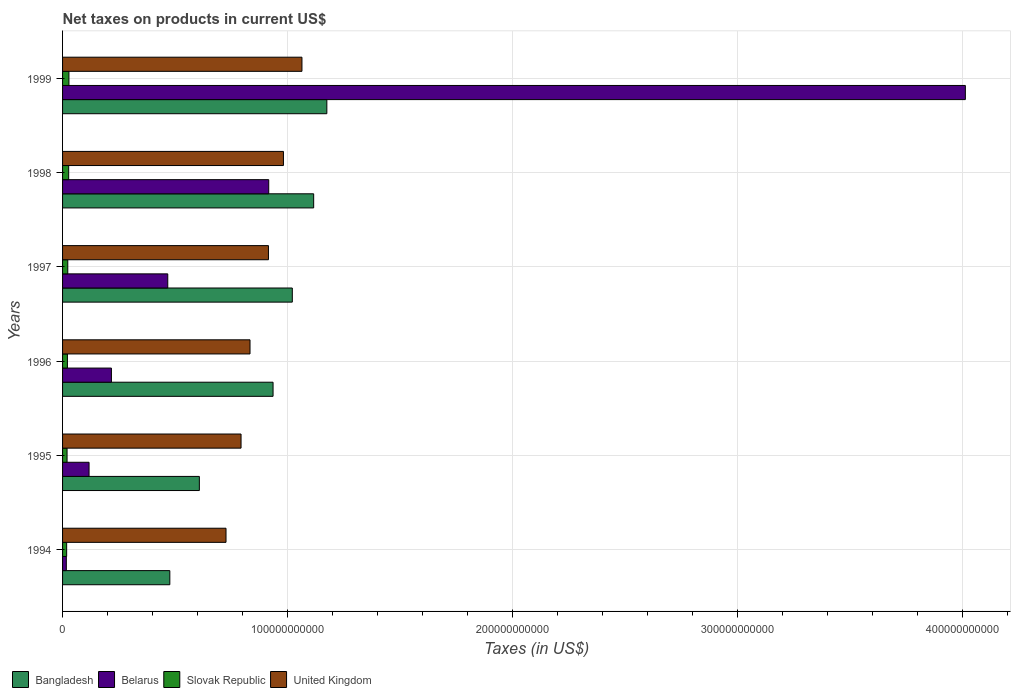How many different coloured bars are there?
Your response must be concise. 4. Are the number of bars per tick equal to the number of legend labels?
Your response must be concise. Yes. How many bars are there on the 4th tick from the top?
Give a very brief answer. 4. How many bars are there on the 5th tick from the bottom?
Your response must be concise. 4. In how many cases, is the number of bars for a given year not equal to the number of legend labels?
Make the answer very short. 0. What is the net taxes on products in Bangladesh in 1997?
Provide a succinct answer. 1.02e+11. Across all years, what is the maximum net taxes on products in United Kingdom?
Keep it short and to the point. 1.06e+11. Across all years, what is the minimum net taxes on products in Bangladesh?
Offer a very short reply. 4.77e+1. What is the total net taxes on products in United Kingdom in the graph?
Ensure brevity in your answer.  5.31e+11. What is the difference between the net taxes on products in United Kingdom in 1997 and that in 1999?
Give a very brief answer. -1.49e+1. What is the difference between the net taxes on products in Bangladesh in 1996 and the net taxes on products in United Kingdom in 1998?
Your answer should be very brief. -4.62e+09. What is the average net taxes on products in Bangladesh per year?
Keep it short and to the point. 8.89e+1. In the year 1994, what is the difference between the net taxes on products in United Kingdom and net taxes on products in Belarus?
Offer a terse response. 7.10e+1. In how many years, is the net taxes on products in United Kingdom greater than 280000000000 US$?
Your answer should be compact. 0. What is the ratio of the net taxes on products in Slovak Republic in 1995 to that in 1999?
Your answer should be very brief. 0.71. Is the difference between the net taxes on products in United Kingdom in 1994 and 1996 greater than the difference between the net taxes on products in Belarus in 1994 and 1996?
Give a very brief answer. Yes. What is the difference between the highest and the second highest net taxes on products in Slovak Republic?
Provide a short and direct response. 1.12e+08. What is the difference between the highest and the lowest net taxes on products in Belarus?
Your response must be concise. 4.00e+11. In how many years, is the net taxes on products in Slovak Republic greater than the average net taxes on products in Slovak Republic taken over all years?
Your answer should be very brief. 3. Is the sum of the net taxes on products in Slovak Republic in 1994 and 1998 greater than the maximum net taxes on products in Bangladesh across all years?
Offer a very short reply. No. Is it the case that in every year, the sum of the net taxes on products in Slovak Republic and net taxes on products in Belarus is greater than the sum of net taxes on products in United Kingdom and net taxes on products in Bangladesh?
Provide a short and direct response. No. What does the 2nd bar from the bottom in 1999 represents?
Your answer should be compact. Belarus. Is it the case that in every year, the sum of the net taxes on products in United Kingdom and net taxes on products in Belarus is greater than the net taxes on products in Bangladesh?
Provide a succinct answer. Yes. How many bars are there?
Ensure brevity in your answer.  24. What is the difference between two consecutive major ticks on the X-axis?
Your answer should be compact. 1.00e+11. Does the graph contain any zero values?
Keep it short and to the point. No. Does the graph contain grids?
Keep it short and to the point. Yes. How are the legend labels stacked?
Your answer should be very brief. Horizontal. What is the title of the graph?
Your answer should be compact. Net taxes on products in current US$. Does "Congo (Democratic)" appear as one of the legend labels in the graph?
Your response must be concise. No. What is the label or title of the X-axis?
Your response must be concise. Taxes (in US$). What is the Taxes (in US$) in Bangladesh in 1994?
Provide a succinct answer. 4.77e+1. What is the Taxes (in US$) of Belarus in 1994?
Offer a terse response. 1.67e+09. What is the Taxes (in US$) in Slovak Republic in 1994?
Offer a terse response. 1.82e+09. What is the Taxes (in US$) in United Kingdom in 1994?
Offer a terse response. 7.26e+1. What is the Taxes (in US$) in Bangladesh in 1995?
Your response must be concise. 6.08e+1. What is the Taxes (in US$) of Belarus in 1995?
Provide a short and direct response. 1.18e+1. What is the Taxes (in US$) of Slovak Republic in 1995?
Provide a succinct answer. 2.00e+09. What is the Taxes (in US$) in United Kingdom in 1995?
Make the answer very short. 7.93e+1. What is the Taxes (in US$) of Bangladesh in 1996?
Make the answer very short. 9.36e+1. What is the Taxes (in US$) in Belarus in 1996?
Offer a terse response. 2.17e+1. What is the Taxes (in US$) of Slovak Republic in 1996?
Your response must be concise. 2.15e+09. What is the Taxes (in US$) in United Kingdom in 1996?
Offer a very short reply. 8.33e+1. What is the Taxes (in US$) of Bangladesh in 1997?
Your response must be concise. 1.02e+11. What is the Taxes (in US$) in Belarus in 1997?
Offer a terse response. 4.68e+1. What is the Taxes (in US$) in Slovak Republic in 1997?
Your answer should be very brief. 2.31e+09. What is the Taxes (in US$) of United Kingdom in 1997?
Offer a terse response. 9.15e+1. What is the Taxes (in US$) of Bangladesh in 1998?
Ensure brevity in your answer.  1.12e+11. What is the Taxes (in US$) of Belarus in 1998?
Your response must be concise. 9.16e+1. What is the Taxes (in US$) of Slovak Republic in 1998?
Provide a succinct answer. 2.72e+09. What is the Taxes (in US$) in United Kingdom in 1998?
Offer a very short reply. 9.82e+1. What is the Taxes (in US$) of Bangladesh in 1999?
Give a very brief answer. 1.17e+11. What is the Taxes (in US$) of Belarus in 1999?
Ensure brevity in your answer.  4.01e+11. What is the Taxes (in US$) of Slovak Republic in 1999?
Your response must be concise. 2.83e+09. What is the Taxes (in US$) in United Kingdom in 1999?
Provide a succinct answer. 1.06e+11. Across all years, what is the maximum Taxes (in US$) of Bangladesh?
Offer a terse response. 1.17e+11. Across all years, what is the maximum Taxes (in US$) in Belarus?
Make the answer very short. 4.01e+11. Across all years, what is the maximum Taxes (in US$) of Slovak Republic?
Ensure brevity in your answer.  2.83e+09. Across all years, what is the maximum Taxes (in US$) in United Kingdom?
Give a very brief answer. 1.06e+11. Across all years, what is the minimum Taxes (in US$) in Bangladesh?
Offer a very short reply. 4.77e+1. Across all years, what is the minimum Taxes (in US$) of Belarus?
Make the answer very short. 1.67e+09. Across all years, what is the minimum Taxes (in US$) of Slovak Republic?
Ensure brevity in your answer.  1.82e+09. Across all years, what is the minimum Taxes (in US$) in United Kingdom?
Offer a terse response. 7.26e+1. What is the total Taxes (in US$) in Bangladesh in the graph?
Give a very brief answer. 5.33e+11. What is the total Taxes (in US$) in Belarus in the graph?
Ensure brevity in your answer.  5.75e+11. What is the total Taxes (in US$) of Slovak Republic in the graph?
Your answer should be very brief. 1.38e+1. What is the total Taxes (in US$) of United Kingdom in the graph?
Make the answer very short. 5.31e+11. What is the difference between the Taxes (in US$) in Bangladesh in 1994 and that in 1995?
Provide a short and direct response. -1.31e+1. What is the difference between the Taxes (in US$) of Belarus in 1994 and that in 1995?
Offer a very short reply. -1.01e+1. What is the difference between the Taxes (in US$) in Slovak Republic in 1994 and that in 1995?
Ensure brevity in your answer.  -1.81e+08. What is the difference between the Taxes (in US$) of United Kingdom in 1994 and that in 1995?
Provide a short and direct response. -6.69e+09. What is the difference between the Taxes (in US$) in Bangladesh in 1994 and that in 1996?
Provide a succinct answer. -4.59e+1. What is the difference between the Taxes (in US$) in Belarus in 1994 and that in 1996?
Your response must be concise. -2.00e+1. What is the difference between the Taxes (in US$) of Slovak Republic in 1994 and that in 1996?
Make the answer very short. -3.37e+08. What is the difference between the Taxes (in US$) in United Kingdom in 1994 and that in 1996?
Offer a very short reply. -1.07e+1. What is the difference between the Taxes (in US$) of Bangladesh in 1994 and that in 1997?
Provide a succinct answer. -5.44e+1. What is the difference between the Taxes (in US$) of Belarus in 1994 and that in 1997?
Provide a succinct answer. -4.51e+1. What is the difference between the Taxes (in US$) of Slovak Republic in 1994 and that in 1997?
Give a very brief answer. -4.97e+08. What is the difference between the Taxes (in US$) in United Kingdom in 1994 and that in 1997?
Make the answer very short. -1.89e+1. What is the difference between the Taxes (in US$) in Bangladesh in 1994 and that in 1998?
Make the answer very short. -6.39e+1. What is the difference between the Taxes (in US$) of Belarus in 1994 and that in 1998?
Make the answer very short. -9.00e+1. What is the difference between the Taxes (in US$) in Slovak Republic in 1994 and that in 1998?
Your response must be concise. -9.05e+08. What is the difference between the Taxes (in US$) in United Kingdom in 1994 and that in 1998?
Provide a succinct answer. -2.55e+1. What is the difference between the Taxes (in US$) in Bangladesh in 1994 and that in 1999?
Give a very brief answer. -6.98e+1. What is the difference between the Taxes (in US$) in Belarus in 1994 and that in 1999?
Provide a succinct answer. -4.00e+11. What is the difference between the Taxes (in US$) of Slovak Republic in 1994 and that in 1999?
Offer a very short reply. -1.02e+09. What is the difference between the Taxes (in US$) in United Kingdom in 1994 and that in 1999?
Keep it short and to the point. -3.38e+1. What is the difference between the Taxes (in US$) of Bangladesh in 1995 and that in 1996?
Make the answer very short. -3.28e+1. What is the difference between the Taxes (in US$) of Belarus in 1995 and that in 1996?
Your answer should be compact. -9.93e+09. What is the difference between the Taxes (in US$) in Slovak Republic in 1995 and that in 1996?
Your response must be concise. -1.56e+08. What is the difference between the Taxes (in US$) of United Kingdom in 1995 and that in 1996?
Your answer should be compact. -3.98e+09. What is the difference between the Taxes (in US$) of Bangladesh in 1995 and that in 1997?
Your response must be concise. -4.13e+1. What is the difference between the Taxes (in US$) of Belarus in 1995 and that in 1997?
Ensure brevity in your answer.  -3.50e+1. What is the difference between the Taxes (in US$) in Slovak Republic in 1995 and that in 1997?
Offer a terse response. -3.16e+08. What is the difference between the Taxes (in US$) in United Kingdom in 1995 and that in 1997?
Provide a succinct answer. -1.22e+1. What is the difference between the Taxes (in US$) in Bangladesh in 1995 and that in 1998?
Your answer should be compact. -5.08e+1. What is the difference between the Taxes (in US$) in Belarus in 1995 and that in 1998?
Offer a terse response. -7.99e+1. What is the difference between the Taxes (in US$) in Slovak Republic in 1995 and that in 1998?
Keep it short and to the point. -7.24e+08. What is the difference between the Taxes (in US$) of United Kingdom in 1995 and that in 1998?
Keep it short and to the point. -1.88e+1. What is the difference between the Taxes (in US$) in Bangladesh in 1995 and that in 1999?
Your answer should be very brief. -5.67e+1. What is the difference between the Taxes (in US$) of Belarus in 1995 and that in 1999?
Make the answer very short. -3.89e+11. What is the difference between the Taxes (in US$) of Slovak Republic in 1995 and that in 1999?
Provide a short and direct response. -8.36e+08. What is the difference between the Taxes (in US$) of United Kingdom in 1995 and that in 1999?
Your answer should be very brief. -2.71e+1. What is the difference between the Taxes (in US$) in Bangladesh in 1996 and that in 1997?
Your answer should be very brief. -8.56e+09. What is the difference between the Taxes (in US$) in Belarus in 1996 and that in 1997?
Provide a succinct answer. -2.50e+1. What is the difference between the Taxes (in US$) in Slovak Republic in 1996 and that in 1997?
Ensure brevity in your answer.  -1.60e+08. What is the difference between the Taxes (in US$) in United Kingdom in 1996 and that in 1997?
Provide a short and direct response. -8.19e+09. What is the difference between the Taxes (in US$) in Bangladesh in 1996 and that in 1998?
Keep it short and to the point. -1.81e+1. What is the difference between the Taxes (in US$) of Belarus in 1996 and that in 1998?
Offer a terse response. -6.99e+1. What is the difference between the Taxes (in US$) of Slovak Republic in 1996 and that in 1998?
Give a very brief answer. -5.68e+08. What is the difference between the Taxes (in US$) in United Kingdom in 1996 and that in 1998?
Keep it short and to the point. -1.49e+1. What is the difference between the Taxes (in US$) of Bangladesh in 1996 and that in 1999?
Provide a short and direct response. -2.39e+1. What is the difference between the Taxes (in US$) in Belarus in 1996 and that in 1999?
Your answer should be compact. -3.80e+11. What is the difference between the Taxes (in US$) in Slovak Republic in 1996 and that in 1999?
Your response must be concise. -6.80e+08. What is the difference between the Taxes (in US$) of United Kingdom in 1996 and that in 1999?
Ensure brevity in your answer.  -2.31e+1. What is the difference between the Taxes (in US$) of Bangladesh in 1997 and that in 1998?
Provide a succinct answer. -9.50e+09. What is the difference between the Taxes (in US$) of Belarus in 1997 and that in 1998?
Provide a short and direct response. -4.49e+1. What is the difference between the Taxes (in US$) in Slovak Republic in 1997 and that in 1998?
Offer a terse response. -4.08e+08. What is the difference between the Taxes (in US$) in United Kingdom in 1997 and that in 1998?
Your response must be concise. -6.66e+09. What is the difference between the Taxes (in US$) of Bangladesh in 1997 and that in 1999?
Offer a terse response. -1.53e+1. What is the difference between the Taxes (in US$) in Belarus in 1997 and that in 1999?
Provide a short and direct response. -3.55e+11. What is the difference between the Taxes (in US$) of Slovak Republic in 1997 and that in 1999?
Provide a succinct answer. -5.20e+08. What is the difference between the Taxes (in US$) in United Kingdom in 1997 and that in 1999?
Make the answer very short. -1.49e+1. What is the difference between the Taxes (in US$) of Bangladesh in 1998 and that in 1999?
Offer a terse response. -5.85e+09. What is the difference between the Taxes (in US$) of Belarus in 1998 and that in 1999?
Provide a succinct answer. -3.10e+11. What is the difference between the Taxes (in US$) of Slovak Republic in 1998 and that in 1999?
Make the answer very short. -1.12e+08. What is the difference between the Taxes (in US$) of United Kingdom in 1998 and that in 1999?
Your answer should be very brief. -8.23e+09. What is the difference between the Taxes (in US$) in Bangladesh in 1994 and the Taxes (in US$) in Belarus in 1995?
Give a very brief answer. 3.59e+1. What is the difference between the Taxes (in US$) of Bangladesh in 1994 and the Taxes (in US$) of Slovak Republic in 1995?
Offer a terse response. 4.57e+1. What is the difference between the Taxes (in US$) of Bangladesh in 1994 and the Taxes (in US$) of United Kingdom in 1995?
Make the answer very short. -3.17e+1. What is the difference between the Taxes (in US$) of Belarus in 1994 and the Taxes (in US$) of Slovak Republic in 1995?
Your response must be concise. -3.25e+08. What is the difference between the Taxes (in US$) in Belarus in 1994 and the Taxes (in US$) in United Kingdom in 1995?
Keep it short and to the point. -7.77e+1. What is the difference between the Taxes (in US$) in Slovak Republic in 1994 and the Taxes (in US$) in United Kingdom in 1995?
Your answer should be compact. -7.75e+1. What is the difference between the Taxes (in US$) in Bangladesh in 1994 and the Taxes (in US$) in Belarus in 1996?
Offer a very short reply. 2.60e+1. What is the difference between the Taxes (in US$) in Bangladesh in 1994 and the Taxes (in US$) in Slovak Republic in 1996?
Give a very brief answer. 4.55e+1. What is the difference between the Taxes (in US$) of Bangladesh in 1994 and the Taxes (in US$) of United Kingdom in 1996?
Your answer should be compact. -3.56e+1. What is the difference between the Taxes (in US$) of Belarus in 1994 and the Taxes (in US$) of Slovak Republic in 1996?
Give a very brief answer. -4.81e+08. What is the difference between the Taxes (in US$) of Belarus in 1994 and the Taxes (in US$) of United Kingdom in 1996?
Offer a very short reply. -8.16e+1. What is the difference between the Taxes (in US$) of Slovak Republic in 1994 and the Taxes (in US$) of United Kingdom in 1996?
Your response must be concise. -8.15e+1. What is the difference between the Taxes (in US$) of Bangladesh in 1994 and the Taxes (in US$) of Belarus in 1997?
Provide a succinct answer. 9.21e+08. What is the difference between the Taxes (in US$) of Bangladesh in 1994 and the Taxes (in US$) of Slovak Republic in 1997?
Ensure brevity in your answer.  4.54e+1. What is the difference between the Taxes (in US$) in Bangladesh in 1994 and the Taxes (in US$) in United Kingdom in 1997?
Your response must be concise. -4.38e+1. What is the difference between the Taxes (in US$) of Belarus in 1994 and the Taxes (in US$) of Slovak Republic in 1997?
Give a very brief answer. -6.41e+08. What is the difference between the Taxes (in US$) of Belarus in 1994 and the Taxes (in US$) of United Kingdom in 1997?
Provide a succinct answer. -8.98e+1. What is the difference between the Taxes (in US$) of Slovak Republic in 1994 and the Taxes (in US$) of United Kingdom in 1997?
Keep it short and to the point. -8.97e+1. What is the difference between the Taxes (in US$) of Bangladesh in 1994 and the Taxes (in US$) of Belarus in 1998?
Offer a terse response. -4.40e+1. What is the difference between the Taxes (in US$) in Bangladesh in 1994 and the Taxes (in US$) in Slovak Republic in 1998?
Your answer should be compact. 4.50e+1. What is the difference between the Taxes (in US$) in Bangladesh in 1994 and the Taxes (in US$) in United Kingdom in 1998?
Your answer should be compact. -5.05e+1. What is the difference between the Taxes (in US$) in Belarus in 1994 and the Taxes (in US$) in Slovak Republic in 1998?
Make the answer very short. -1.05e+09. What is the difference between the Taxes (in US$) of Belarus in 1994 and the Taxes (in US$) of United Kingdom in 1998?
Ensure brevity in your answer.  -9.65e+1. What is the difference between the Taxes (in US$) in Slovak Republic in 1994 and the Taxes (in US$) in United Kingdom in 1998?
Make the answer very short. -9.64e+1. What is the difference between the Taxes (in US$) of Bangladesh in 1994 and the Taxes (in US$) of Belarus in 1999?
Your answer should be compact. -3.54e+11. What is the difference between the Taxes (in US$) of Bangladesh in 1994 and the Taxes (in US$) of Slovak Republic in 1999?
Offer a very short reply. 4.48e+1. What is the difference between the Taxes (in US$) of Bangladesh in 1994 and the Taxes (in US$) of United Kingdom in 1999?
Your response must be concise. -5.87e+1. What is the difference between the Taxes (in US$) in Belarus in 1994 and the Taxes (in US$) in Slovak Republic in 1999?
Your answer should be compact. -1.16e+09. What is the difference between the Taxes (in US$) of Belarus in 1994 and the Taxes (in US$) of United Kingdom in 1999?
Provide a short and direct response. -1.05e+11. What is the difference between the Taxes (in US$) in Slovak Republic in 1994 and the Taxes (in US$) in United Kingdom in 1999?
Provide a short and direct response. -1.05e+11. What is the difference between the Taxes (in US$) of Bangladesh in 1995 and the Taxes (in US$) of Belarus in 1996?
Give a very brief answer. 3.91e+1. What is the difference between the Taxes (in US$) in Bangladesh in 1995 and the Taxes (in US$) in Slovak Republic in 1996?
Provide a short and direct response. 5.86e+1. What is the difference between the Taxes (in US$) in Bangladesh in 1995 and the Taxes (in US$) in United Kingdom in 1996?
Make the answer very short. -2.25e+1. What is the difference between the Taxes (in US$) in Belarus in 1995 and the Taxes (in US$) in Slovak Republic in 1996?
Provide a short and direct response. 9.62e+09. What is the difference between the Taxes (in US$) of Belarus in 1995 and the Taxes (in US$) of United Kingdom in 1996?
Make the answer very short. -7.15e+1. What is the difference between the Taxes (in US$) in Slovak Republic in 1995 and the Taxes (in US$) in United Kingdom in 1996?
Offer a terse response. -8.13e+1. What is the difference between the Taxes (in US$) in Bangladesh in 1995 and the Taxes (in US$) in Belarus in 1997?
Keep it short and to the point. 1.40e+1. What is the difference between the Taxes (in US$) of Bangladesh in 1995 and the Taxes (in US$) of Slovak Republic in 1997?
Ensure brevity in your answer.  5.85e+1. What is the difference between the Taxes (in US$) in Bangladesh in 1995 and the Taxes (in US$) in United Kingdom in 1997?
Keep it short and to the point. -3.07e+1. What is the difference between the Taxes (in US$) in Belarus in 1995 and the Taxes (in US$) in Slovak Republic in 1997?
Your answer should be compact. 9.46e+09. What is the difference between the Taxes (in US$) in Belarus in 1995 and the Taxes (in US$) in United Kingdom in 1997?
Your answer should be very brief. -7.97e+1. What is the difference between the Taxes (in US$) of Slovak Republic in 1995 and the Taxes (in US$) of United Kingdom in 1997?
Your answer should be very brief. -8.95e+1. What is the difference between the Taxes (in US$) of Bangladesh in 1995 and the Taxes (in US$) of Belarus in 1998?
Offer a very short reply. -3.08e+1. What is the difference between the Taxes (in US$) in Bangladesh in 1995 and the Taxes (in US$) in Slovak Republic in 1998?
Keep it short and to the point. 5.81e+1. What is the difference between the Taxes (in US$) of Bangladesh in 1995 and the Taxes (in US$) of United Kingdom in 1998?
Your response must be concise. -3.74e+1. What is the difference between the Taxes (in US$) of Belarus in 1995 and the Taxes (in US$) of Slovak Republic in 1998?
Give a very brief answer. 9.05e+09. What is the difference between the Taxes (in US$) of Belarus in 1995 and the Taxes (in US$) of United Kingdom in 1998?
Offer a terse response. -8.64e+1. What is the difference between the Taxes (in US$) in Slovak Republic in 1995 and the Taxes (in US$) in United Kingdom in 1998?
Offer a very short reply. -9.62e+1. What is the difference between the Taxes (in US$) of Bangladesh in 1995 and the Taxes (in US$) of Belarus in 1999?
Provide a short and direct response. -3.40e+11. What is the difference between the Taxes (in US$) in Bangladesh in 1995 and the Taxes (in US$) in Slovak Republic in 1999?
Offer a terse response. 5.80e+1. What is the difference between the Taxes (in US$) of Bangladesh in 1995 and the Taxes (in US$) of United Kingdom in 1999?
Provide a short and direct response. -4.56e+1. What is the difference between the Taxes (in US$) of Belarus in 1995 and the Taxes (in US$) of Slovak Republic in 1999?
Offer a very short reply. 8.94e+09. What is the difference between the Taxes (in US$) of Belarus in 1995 and the Taxes (in US$) of United Kingdom in 1999?
Ensure brevity in your answer.  -9.46e+1. What is the difference between the Taxes (in US$) in Slovak Republic in 1995 and the Taxes (in US$) in United Kingdom in 1999?
Give a very brief answer. -1.04e+11. What is the difference between the Taxes (in US$) of Bangladesh in 1996 and the Taxes (in US$) of Belarus in 1997?
Provide a succinct answer. 4.68e+1. What is the difference between the Taxes (in US$) of Bangladesh in 1996 and the Taxes (in US$) of Slovak Republic in 1997?
Give a very brief answer. 9.12e+1. What is the difference between the Taxes (in US$) in Bangladesh in 1996 and the Taxes (in US$) in United Kingdom in 1997?
Keep it short and to the point. 2.05e+09. What is the difference between the Taxes (in US$) of Belarus in 1996 and the Taxes (in US$) of Slovak Republic in 1997?
Your answer should be very brief. 1.94e+1. What is the difference between the Taxes (in US$) in Belarus in 1996 and the Taxes (in US$) in United Kingdom in 1997?
Offer a very short reply. -6.98e+1. What is the difference between the Taxes (in US$) of Slovak Republic in 1996 and the Taxes (in US$) of United Kingdom in 1997?
Give a very brief answer. -8.94e+1. What is the difference between the Taxes (in US$) in Bangladesh in 1996 and the Taxes (in US$) in Belarus in 1998?
Keep it short and to the point. 1.92e+09. What is the difference between the Taxes (in US$) of Bangladesh in 1996 and the Taxes (in US$) of Slovak Republic in 1998?
Offer a very short reply. 9.08e+1. What is the difference between the Taxes (in US$) of Bangladesh in 1996 and the Taxes (in US$) of United Kingdom in 1998?
Your response must be concise. -4.62e+09. What is the difference between the Taxes (in US$) in Belarus in 1996 and the Taxes (in US$) in Slovak Republic in 1998?
Keep it short and to the point. 1.90e+1. What is the difference between the Taxes (in US$) in Belarus in 1996 and the Taxes (in US$) in United Kingdom in 1998?
Offer a terse response. -7.65e+1. What is the difference between the Taxes (in US$) of Slovak Republic in 1996 and the Taxes (in US$) of United Kingdom in 1998?
Provide a short and direct response. -9.60e+1. What is the difference between the Taxes (in US$) of Bangladesh in 1996 and the Taxes (in US$) of Belarus in 1999?
Make the answer very short. -3.08e+11. What is the difference between the Taxes (in US$) of Bangladesh in 1996 and the Taxes (in US$) of Slovak Republic in 1999?
Your answer should be very brief. 9.07e+1. What is the difference between the Taxes (in US$) of Bangladesh in 1996 and the Taxes (in US$) of United Kingdom in 1999?
Offer a terse response. -1.28e+1. What is the difference between the Taxes (in US$) of Belarus in 1996 and the Taxes (in US$) of Slovak Republic in 1999?
Provide a succinct answer. 1.89e+1. What is the difference between the Taxes (in US$) in Belarus in 1996 and the Taxes (in US$) in United Kingdom in 1999?
Provide a short and direct response. -8.47e+1. What is the difference between the Taxes (in US$) in Slovak Republic in 1996 and the Taxes (in US$) in United Kingdom in 1999?
Make the answer very short. -1.04e+11. What is the difference between the Taxes (in US$) in Bangladesh in 1997 and the Taxes (in US$) in Belarus in 1998?
Give a very brief answer. 1.05e+1. What is the difference between the Taxes (in US$) in Bangladesh in 1997 and the Taxes (in US$) in Slovak Republic in 1998?
Keep it short and to the point. 9.94e+1. What is the difference between the Taxes (in US$) of Bangladesh in 1997 and the Taxes (in US$) of United Kingdom in 1998?
Make the answer very short. 3.94e+09. What is the difference between the Taxes (in US$) in Belarus in 1997 and the Taxes (in US$) in Slovak Republic in 1998?
Give a very brief answer. 4.40e+1. What is the difference between the Taxes (in US$) of Belarus in 1997 and the Taxes (in US$) of United Kingdom in 1998?
Make the answer very short. -5.14e+1. What is the difference between the Taxes (in US$) of Slovak Republic in 1997 and the Taxes (in US$) of United Kingdom in 1998?
Keep it short and to the point. -9.59e+1. What is the difference between the Taxes (in US$) of Bangladesh in 1997 and the Taxes (in US$) of Belarus in 1999?
Give a very brief answer. -2.99e+11. What is the difference between the Taxes (in US$) of Bangladesh in 1997 and the Taxes (in US$) of Slovak Republic in 1999?
Offer a very short reply. 9.93e+1. What is the difference between the Taxes (in US$) of Bangladesh in 1997 and the Taxes (in US$) of United Kingdom in 1999?
Make the answer very short. -4.29e+09. What is the difference between the Taxes (in US$) of Belarus in 1997 and the Taxes (in US$) of Slovak Republic in 1999?
Offer a terse response. 4.39e+1. What is the difference between the Taxes (in US$) of Belarus in 1997 and the Taxes (in US$) of United Kingdom in 1999?
Keep it short and to the point. -5.96e+1. What is the difference between the Taxes (in US$) in Slovak Republic in 1997 and the Taxes (in US$) in United Kingdom in 1999?
Provide a succinct answer. -1.04e+11. What is the difference between the Taxes (in US$) in Bangladesh in 1998 and the Taxes (in US$) in Belarus in 1999?
Your answer should be compact. -2.90e+11. What is the difference between the Taxes (in US$) in Bangladesh in 1998 and the Taxes (in US$) in Slovak Republic in 1999?
Offer a terse response. 1.09e+11. What is the difference between the Taxes (in US$) in Bangladesh in 1998 and the Taxes (in US$) in United Kingdom in 1999?
Your answer should be compact. 5.21e+09. What is the difference between the Taxes (in US$) of Belarus in 1998 and the Taxes (in US$) of Slovak Republic in 1999?
Make the answer very short. 8.88e+1. What is the difference between the Taxes (in US$) of Belarus in 1998 and the Taxes (in US$) of United Kingdom in 1999?
Ensure brevity in your answer.  -1.48e+1. What is the difference between the Taxes (in US$) in Slovak Republic in 1998 and the Taxes (in US$) in United Kingdom in 1999?
Ensure brevity in your answer.  -1.04e+11. What is the average Taxes (in US$) in Bangladesh per year?
Offer a very short reply. 8.89e+1. What is the average Taxes (in US$) of Belarus per year?
Offer a terse response. 9.58e+1. What is the average Taxes (in US$) of Slovak Republic per year?
Your answer should be very brief. 2.31e+09. What is the average Taxes (in US$) in United Kingdom per year?
Keep it short and to the point. 8.86e+1. In the year 1994, what is the difference between the Taxes (in US$) in Bangladesh and Taxes (in US$) in Belarus?
Provide a succinct answer. 4.60e+1. In the year 1994, what is the difference between the Taxes (in US$) in Bangladesh and Taxes (in US$) in Slovak Republic?
Keep it short and to the point. 4.59e+1. In the year 1994, what is the difference between the Taxes (in US$) in Bangladesh and Taxes (in US$) in United Kingdom?
Provide a succinct answer. -2.50e+1. In the year 1994, what is the difference between the Taxes (in US$) of Belarus and Taxes (in US$) of Slovak Republic?
Offer a very short reply. -1.44e+08. In the year 1994, what is the difference between the Taxes (in US$) in Belarus and Taxes (in US$) in United Kingdom?
Make the answer very short. -7.10e+1. In the year 1994, what is the difference between the Taxes (in US$) of Slovak Republic and Taxes (in US$) of United Kingdom?
Your response must be concise. -7.08e+1. In the year 1995, what is the difference between the Taxes (in US$) in Bangladesh and Taxes (in US$) in Belarus?
Your answer should be very brief. 4.90e+1. In the year 1995, what is the difference between the Taxes (in US$) of Bangladesh and Taxes (in US$) of Slovak Republic?
Your response must be concise. 5.88e+1. In the year 1995, what is the difference between the Taxes (in US$) of Bangladesh and Taxes (in US$) of United Kingdom?
Offer a terse response. -1.85e+1. In the year 1995, what is the difference between the Taxes (in US$) in Belarus and Taxes (in US$) in Slovak Republic?
Offer a terse response. 9.78e+09. In the year 1995, what is the difference between the Taxes (in US$) in Belarus and Taxes (in US$) in United Kingdom?
Your response must be concise. -6.76e+1. In the year 1995, what is the difference between the Taxes (in US$) of Slovak Republic and Taxes (in US$) of United Kingdom?
Provide a succinct answer. -7.73e+1. In the year 1996, what is the difference between the Taxes (in US$) of Bangladesh and Taxes (in US$) of Belarus?
Your answer should be compact. 7.18e+1. In the year 1996, what is the difference between the Taxes (in US$) in Bangladesh and Taxes (in US$) in Slovak Republic?
Offer a very short reply. 9.14e+1. In the year 1996, what is the difference between the Taxes (in US$) of Bangladesh and Taxes (in US$) of United Kingdom?
Keep it short and to the point. 1.02e+1. In the year 1996, what is the difference between the Taxes (in US$) of Belarus and Taxes (in US$) of Slovak Republic?
Keep it short and to the point. 1.96e+1. In the year 1996, what is the difference between the Taxes (in US$) in Belarus and Taxes (in US$) in United Kingdom?
Offer a terse response. -6.16e+1. In the year 1996, what is the difference between the Taxes (in US$) of Slovak Republic and Taxes (in US$) of United Kingdom?
Your response must be concise. -8.12e+1. In the year 1997, what is the difference between the Taxes (in US$) in Bangladesh and Taxes (in US$) in Belarus?
Your answer should be very brief. 5.54e+1. In the year 1997, what is the difference between the Taxes (in US$) in Bangladesh and Taxes (in US$) in Slovak Republic?
Keep it short and to the point. 9.98e+1. In the year 1997, what is the difference between the Taxes (in US$) in Bangladesh and Taxes (in US$) in United Kingdom?
Offer a very short reply. 1.06e+1. In the year 1997, what is the difference between the Taxes (in US$) in Belarus and Taxes (in US$) in Slovak Republic?
Offer a terse response. 4.44e+1. In the year 1997, what is the difference between the Taxes (in US$) of Belarus and Taxes (in US$) of United Kingdom?
Your answer should be very brief. -4.48e+1. In the year 1997, what is the difference between the Taxes (in US$) in Slovak Republic and Taxes (in US$) in United Kingdom?
Ensure brevity in your answer.  -8.92e+1. In the year 1998, what is the difference between the Taxes (in US$) of Bangladesh and Taxes (in US$) of Belarus?
Provide a succinct answer. 2.00e+1. In the year 1998, what is the difference between the Taxes (in US$) in Bangladesh and Taxes (in US$) in Slovak Republic?
Offer a terse response. 1.09e+11. In the year 1998, what is the difference between the Taxes (in US$) in Bangladesh and Taxes (in US$) in United Kingdom?
Your answer should be very brief. 1.34e+1. In the year 1998, what is the difference between the Taxes (in US$) in Belarus and Taxes (in US$) in Slovak Republic?
Offer a very short reply. 8.89e+1. In the year 1998, what is the difference between the Taxes (in US$) of Belarus and Taxes (in US$) of United Kingdom?
Your answer should be very brief. -6.53e+09. In the year 1998, what is the difference between the Taxes (in US$) of Slovak Republic and Taxes (in US$) of United Kingdom?
Your answer should be compact. -9.54e+1. In the year 1999, what is the difference between the Taxes (in US$) of Bangladesh and Taxes (in US$) of Belarus?
Offer a terse response. -2.84e+11. In the year 1999, what is the difference between the Taxes (in US$) of Bangladesh and Taxes (in US$) of Slovak Republic?
Keep it short and to the point. 1.15e+11. In the year 1999, what is the difference between the Taxes (in US$) of Bangladesh and Taxes (in US$) of United Kingdom?
Provide a succinct answer. 1.11e+1. In the year 1999, what is the difference between the Taxes (in US$) of Belarus and Taxes (in US$) of Slovak Republic?
Provide a succinct answer. 3.98e+11. In the year 1999, what is the difference between the Taxes (in US$) of Belarus and Taxes (in US$) of United Kingdom?
Offer a terse response. 2.95e+11. In the year 1999, what is the difference between the Taxes (in US$) of Slovak Republic and Taxes (in US$) of United Kingdom?
Keep it short and to the point. -1.04e+11. What is the ratio of the Taxes (in US$) of Bangladesh in 1994 to that in 1995?
Offer a terse response. 0.78. What is the ratio of the Taxes (in US$) of Belarus in 1994 to that in 1995?
Your answer should be compact. 0.14. What is the ratio of the Taxes (in US$) in Slovak Republic in 1994 to that in 1995?
Your response must be concise. 0.91. What is the ratio of the Taxes (in US$) of United Kingdom in 1994 to that in 1995?
Your answer should be very brief. 0.92. What is the ratio of the Taxes (in US$) of Bangladesh in 1994 to that in 1996?
Your answer should be very brief. 0.51. What is the ratio of the Taxes (in US$) of Belarus in 1994 to that in 1996?
Ensure brevity in your answer.  0.08. What is the ratio of the Taxes (in US$) of Slovak Republic in 1994 to that in 1996?
Your answer should be very brief. 0.84. What is the ratio of the Taxes (in US$) in United Kingdom in 1994 to that in 1996?
Provide a succinct answer. 0.87. What is the ratio of the Taxes (in US$) of Bangladesh in 1994 to that in 1997?
Ensure brevity in your answer.  0.47. What is the ratio of the Taxes (in US$) in Belarus in 1994 to that in 1997?
Your answer should be very brief. 0.04. What is the ratio of the Taxes (in US$) in Slovak Republic in 1994 to that in 1997?
Provide a succinct answer. 0.79. What is the ratio of the Taxes (in US$) in United Kingdom in 1994 to that in 1997?
Ensure brevity in your answer.  0.79. What is the ratio of the Taxes (in US$) in Bangladesh in 1994 to that in 1998?
Offer a very short reply. 0.43. What is the ratio of the Taxes (in US$) of Belarus in 1994 to that in 1998?
Keep it short and to the point. 0.02. What is the ratio of the Taxes (in US$) of Slovak Republic in 1994 to that in 1998?
Make the answer very short. 0.67. What is the ratio of the Taxes (in US$) in United Kingdom in 1994 to that in 1998?
Your answer should be very brief. 0.74. What is the ratio of the Taxes (in US$) of Bangladesh in 1994 to that in 1999?
Offer a very short reply. 0.41. What is the ratio of the Taxes (in US$) of Belarus in 1994 to that in 1999?
Your response must be concise. 0. What is the ratio of the Taxes (in US$) of Slovak Republic in 1994 to that in 1999?
Your answer should be compact. 0.64. What is the ratio of the Taxes (in US$) of United Kingdom in 1994 to that in 1999?
Ensure brevity in your answer.  0.68. What is the ratio of the Taxes (in US$) of Bangladesh in 1995 to that in 1996?
Your response must be concise. 0.65. What is the ratio of the Taxes (in US$) of Belarus in 1995 to that in 1996?
Your answer should be compact. 0.54. What is the ratio of the Taxes (in US$) of Slovak Republic in 1995 to that in 1996?
Your answer should be very brief. 0.93. What is the ratio of the Taxes (in US$) in United Kingdom in 1995 to that in 1996?
Your answer should be very brief. 0.95. What is the ratio of the Taxes (in US$) in Bangladesh in 1995 to that in 1997?
Provide a succinct answer. 0.6. What is the ratio of the Taxes (in US$) in Belarus in 1995 to that in 1997?
Offer a very short reply. 0.25. What is the ratio of the Taxes (in US$) of Slovak Republic in 1995 to that in 1997?
Make the answer very short. 0.86. What is the ratio of the Taxes (in US$) in United Kingdom in 1995 to that in 1997?
Offer a terse response. 0.87. What is the ratio of the Taxes (in US$) of Bangladesh in 1995 to that in 1998?
Ensure brevity in your answer.  0.54. What is the ratio of the Taxes (in US$) in Belarus in 1995 to that in 1998?
Ensure brevity in your answer.  0.13. What is the ratio of the Taxes (in US$) of Slovak Republic in 1995 to that in 1998?
Keep it short and to the point. 0.73. What is the ratio of the Taxes (in US$) of United Kingdom in 1995 to that in 1998?
Ensure brevity in your answer.  0.81. What is the ratio of the Taxes (in US$) of Bangladesh in 1995 to that in 1999?
Give a very brief answer. 0.52. What is the ratio of the Taxes (in US$) in Belarus in 1995 to that in 1999?
Keep it short and to the point. 0.03. What is the ratio of the Taxes (in US$) of Slovak Republic in 1995 to that in 1999?
Ensure brevity in your answer.  0.71. What is the ratio of the Taxes (in US$) in United Kingdom in 1995 to that in 1999?
Offer a terse response. 0.75. What is the ratio of the Taxes (in US$) in Bangladesh in 1996 to that in 1997?
Offer a very short reply. 0.92. What is the ratio of the Taxes (in US$) in Belarus in 1996 to that in 1997?
Your answer should be very brief. 0.46. What is the ratio of the Taxes (in US$) of Slovak Republic in 1996 to that in 1997?
Provide a succinct answer. 0.93. What is the ratio of the Taxes (in US$) of United Kingdom in 1996 to that in 1997?
Your response must be concise. 0.91. What is the ratio of the Taxes (in US$) in Bangladesh in 1996 to that in 1998?
Keep it short and to the point. 0.84. What is the ratio of the Taxes (in US$) in Belarus in 1996 to that in 1998?
Your response must be concise. 0.24. What is the ratio of the Taxes (in US$) in Slovak Republic in 1996 to that in 1998?
Provide a succinct answer. 0.79. What is the ratio of the Taxes (in US$) in United Kingdom in 1996 to that in 1998?
Provide a succinct answer. 0.85. What is the ratio of the Taxes (in US$) of Bangladesh in 1996 to that in 1999?
Provide a succinct answer. 0.8. What is the ratio of the Taxes (in US$) in Belarus in 1996 to that in 1999?
Your answer should be compact. 0.05. What is the ratio of the Taxes (in US$) of Slovak Republic in 1996 to that in 1999?
Offer a terse response. 0.76. What is the ratio of the Taxes (in US$) of United Kingdom in 1996 to that in 1999?
Your answer should be compact. 0.78. What is the ratio of the Taxes (in US$) of Bangladesh in 1997 to that in 1998?
Offer a very short reply. 0.91. What is the ratio of the Taxes (in US$) in Belarus in 1997 to that in 1998?
Your answer should be compact. 0.51. What is the ratio of the Taxes (in US$) in Slovak Republic in 1997 to that in 1998?
Keep it short and to the point. 0.85. What is the ratio of the Taxes (in US$) of United Kingdom in 1997 to that in 1998?
Offer a terse response. 0.93. What is the ratio of the Taxes (in US$) of Bangladesh in 1997 to that in 1999?
Offer a terse response. 0.87. What is the ratio of the Taxes (in US$) of Belarus in 1997 to that in 1999?
Your answer should be compact. 0.12. What is the ratio of the Taxes (in US$) in Slovak Republic in 1997 to that in 1999?
Give a very brief answer. 0.82. What is the ratio of the Taxes (in US$) of United Kingdom in 1997 to that in 1999?
Provide a succinct answer. 0.86. What is the ratio of the Taxes (in US$) in Bangladesh in 1998 to that in 1999?
Your answer should be compact. 0.95. What is the ratio of the Taxes (in US$) in Belarus in 1998 to that in 1999?
Your answer should be compact. 0.23. What is the ratio of the Taxes (in US$) in Slovak Republic in 1998 to that in 1999?
Offer a terse response. 0.96. What is the ratio of the Taxes (in US$) in United Kingdom in 1998 to that in 1999?
Make the answer very short. 0.92. What is the difference between the highest and the second highest Taxes (in US$) of Bangladesh?
Your answer should be compact. 5.85e+09. What is the difference between the highest and the second highest Taxes (in US$) in Belarus?
Offer a terse response. 3.10e+11. What is the difference between the highest and the second highest Taxes (in US$) of Slovak Republic?
Provide a short and direct response. 1.12e+08. What is the difference between the highest and the second highest Taxes (in US$) of United Kingdom?
Give a very brief answer. 8.23e+09. What is the difference between the highest and the lowest Taxes (in US$) of Bangladesh?
Ensure brevity in your answer.  6.98e+1. What is the difference between the highest and the lowest Taxes (in US$) in Belarus?
Ensure brevity in your answer.  4.00e+11. What is the difference between the highest and the lowest Taxes (in US$) of Slovak Republic?
Your answer should be compact. 1.02e+09. What is the difference between the highest and the lowest Taxes (in US$) of United Kingdom?
Keep it short and to the point. 3.38e+1. 